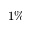<formula> <loc_0><loc_0><loc_500><loc_500>1 \%</formula> 